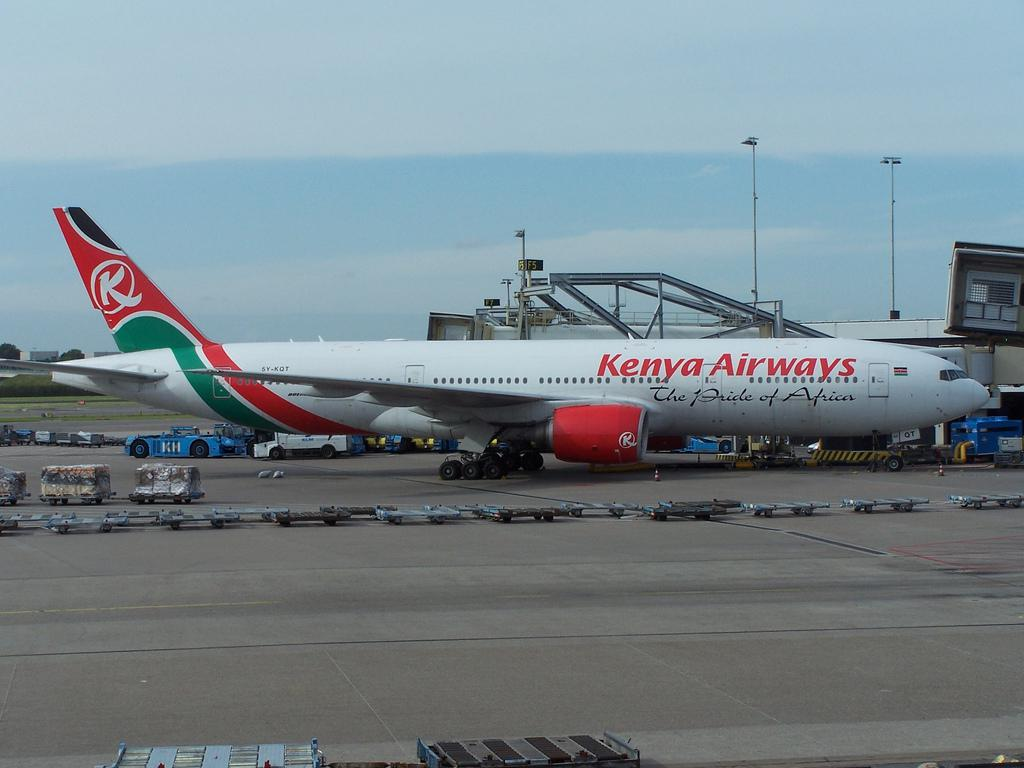Question: what color is the plane?
Choices:
A. Silver.
B. Green, black,red, and white.
C. Yellow.
D. Orange.
Answer with the letter. Answer: B Question: why is the plane stationary?
Choices:
A. It is broken.
B. It is preparing for take-off.
C. It is parked.
D. It is being built.
Answer with the letter. Answer: C Question: who is on the tarmac?
Choices:
A. Crew workers.
B. No one.
C. Pilot.
D. Someone.
Answer with the letter. Answer: B Question: where is the photo taken?
Choices:
A. The hotel.
B. On a Kenya Airways runway.
C. The house.
D. The street.
Answer with the letter. Answer: B Question: what does the plane have under it?
Choices:
A. The runway.
B. Concrete.
C. Wheels.
D. Workers.
Answer with the letter. Answer: C Question: what does the plane say?
Choices:
A. Kenya airways.
B. Air New Zealand.
C. Singapore Airlines.
D. Lufthansa.
Answer with the letter. Answer: A Question: what color is the plane?
Choices:
A. Black and Blue.
B. Yellow and green.
C. White and gold.
D. White, green and red.
Answer with the letter. Answer: D Question: what is in the runway?
Choices:
A. Maintenance people.
B. Painted markings.
C. Stray dog.
D. Carts.
Answer with the letter. Answer: D Question: how are the plane doors?
Choices:
A. Open.
B. Closed.
C. Being secured.
D. Colorfully painted.
Answer with the letter. Answer: B Question: how is the weather?
Choices:
A. Rainy.
B. Sunny.
C. Cloudy.
D. Windy.
Answer with the letter. Answer: C Question: where was the photo taken?
Choices:
A. A helipad.
B. Near a military base.
C. An airport.
D. The beach.
Answer with the letter. Answer: C Question: where is the airplane parked?
Choices:
A. At the terminal.
B. On the runway.
C. In the field.
D. At the gate.
Answer with the letter. Answer: D Question: what airline does the plane belong to?
Choices:
A. Southwest Airlines.
B. Delta Airlines.
C. JetBlue Airlines.
D. Kenya airlines.
Answer with the letter. Answer: D Question: what surrounds the plane?
Choices:
A. Baggage.
B. Air marshals.
C. Airport vehicles.
D. Orange traffic cones.
Answer with the letter. Answer: C Question: who awaits their next task?
Choices:
A. A line of trucks.
B. A line of cars.
C. A group of buses.
D. A group of motorcycles.
Answer with the letter. Answer: B Question: how many people can be seen?
Choices:
A. None.
B. One.
C. Two.
D. Three.
Answer with the letter. Answer: A Question: what kind of pallets line the airstrip?
Choices:
A. Urns and caskets.
B. Baggage.
C. Animal cages.
D. Mail packages.
Answer with the letter. Answer: B Question: how does the sky look?
Choices:
A. Mostly sunny.
B. Partly cloudy.
C. Stormy.
D. Overcast.
Answer with the letter. Answer: D 